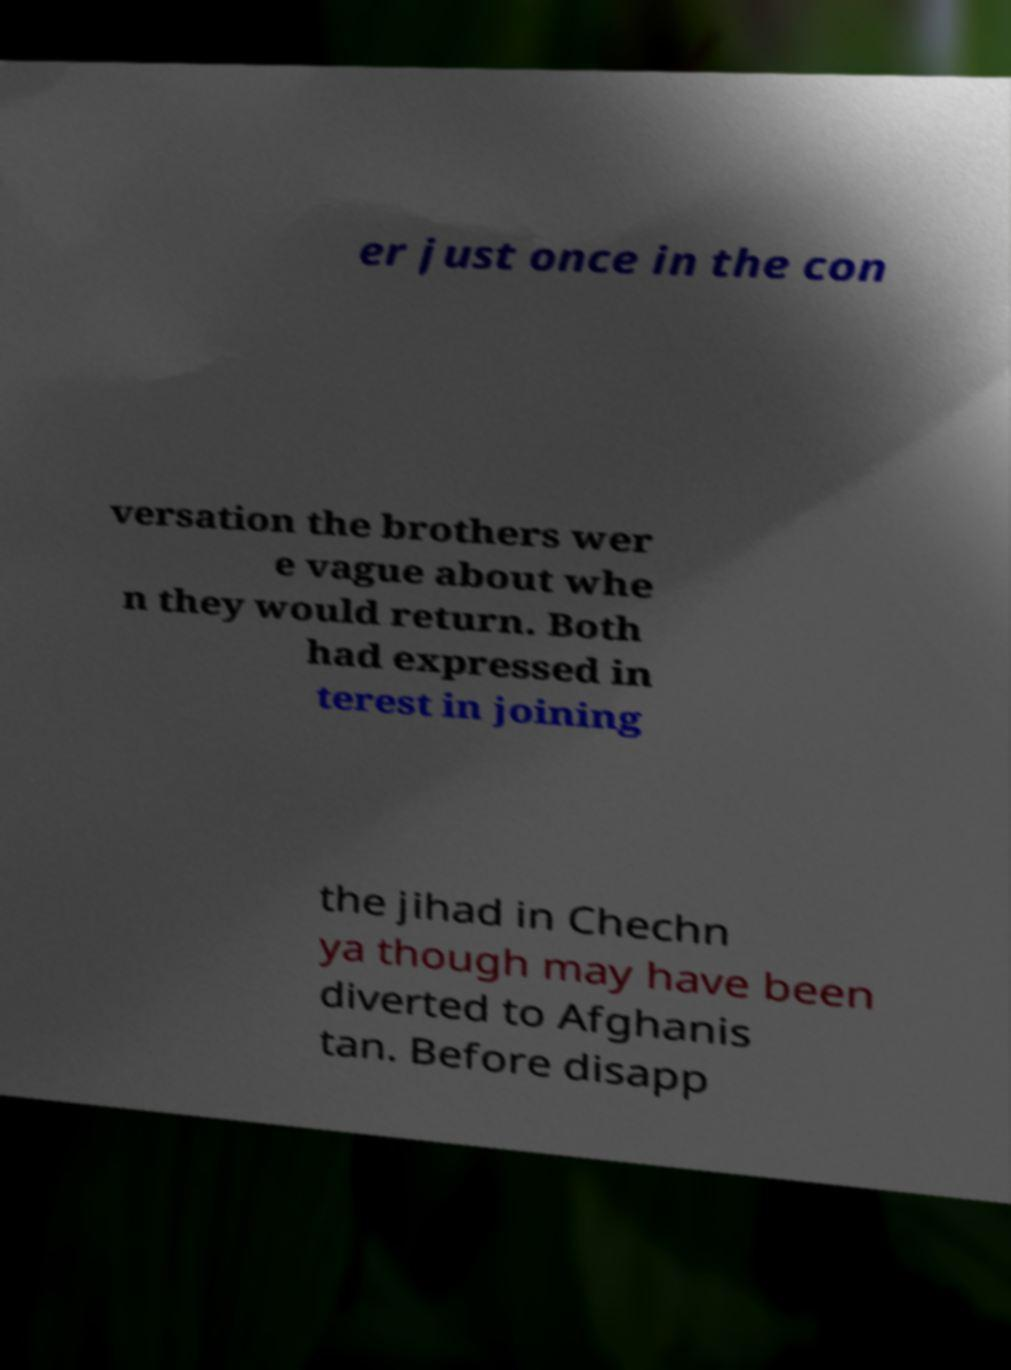Please read and relay the text visible in this image. What does it say? er just once in the con versation the brothers wer e vague about whe n they would return. Both had expressed in terest in joining the jihad in Chechn ya though may have been diverted to Afghanis tan. Before disapp 